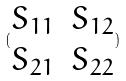Convert formula to latex. <formula><loc_0><loc_0><loc_500><loc_500>( \begin{matrix} S _ { 1 1 } & S _ { 1 2 } \\ S _ { 2 1 } & S _ { 2 2 } \end{matrix} )</formula> 